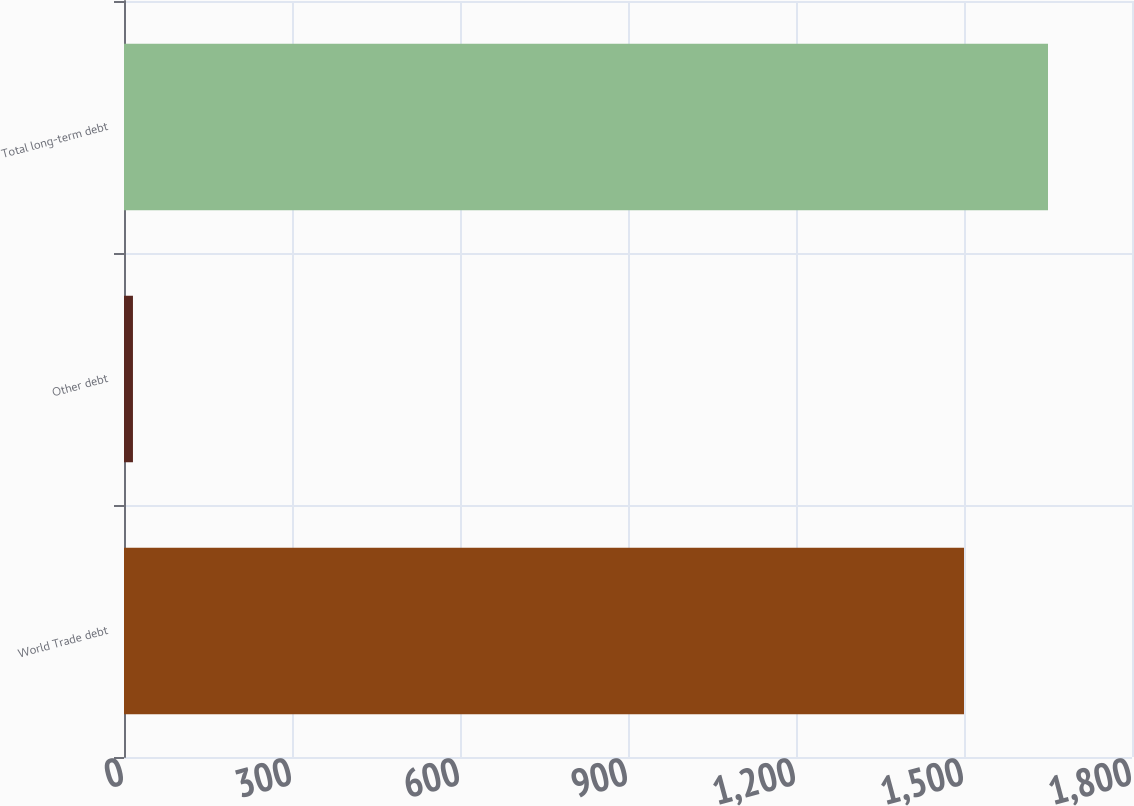Convert chart to OTSL. <chart><loc_0><loc_0><loc_500><loc_500><bar_chart><fcel>World Trade debt<fcel>Other debt<fcel>Total long-term debt<nl><fcel>1500<fcel>16<fcel>1650<nl></chart> 